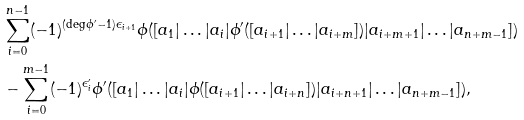Convert formula to latex. <formula><loc_0><loc_0><loc_500><loc_500>& \sum _ { i = 0 } ^ { n - 1 } ( - 1 ) ^ { ( \deg \phi ^ { \prime } - 1 ) \epsilon _ { i + 1 } } \phi ( [ a _ { 1 } | \dots | a _ { i } | \phi ^ { \prime } ( [ a _ { i + 1 } | \dots | a _ { i + m } ] ) | a _ { i + m + 1 } | \dots | a _ { n + m - 1 } ] ) \\ & - \sum _ { i = 0 } ^ { m - 1 } ( - 1 ) ^ { \epsilon _ { i } ^ { \prime } } \phi ^ { \prime } ( [ a _ { 1 } | \dots | a _ { i } | \phi ( [ a _ { i + 1 } | \dots | a _ { i + n } ] ) | a _ { i + n + 1 } | \dots | a _ { n + m - 1 } ] ) ,</formula> 